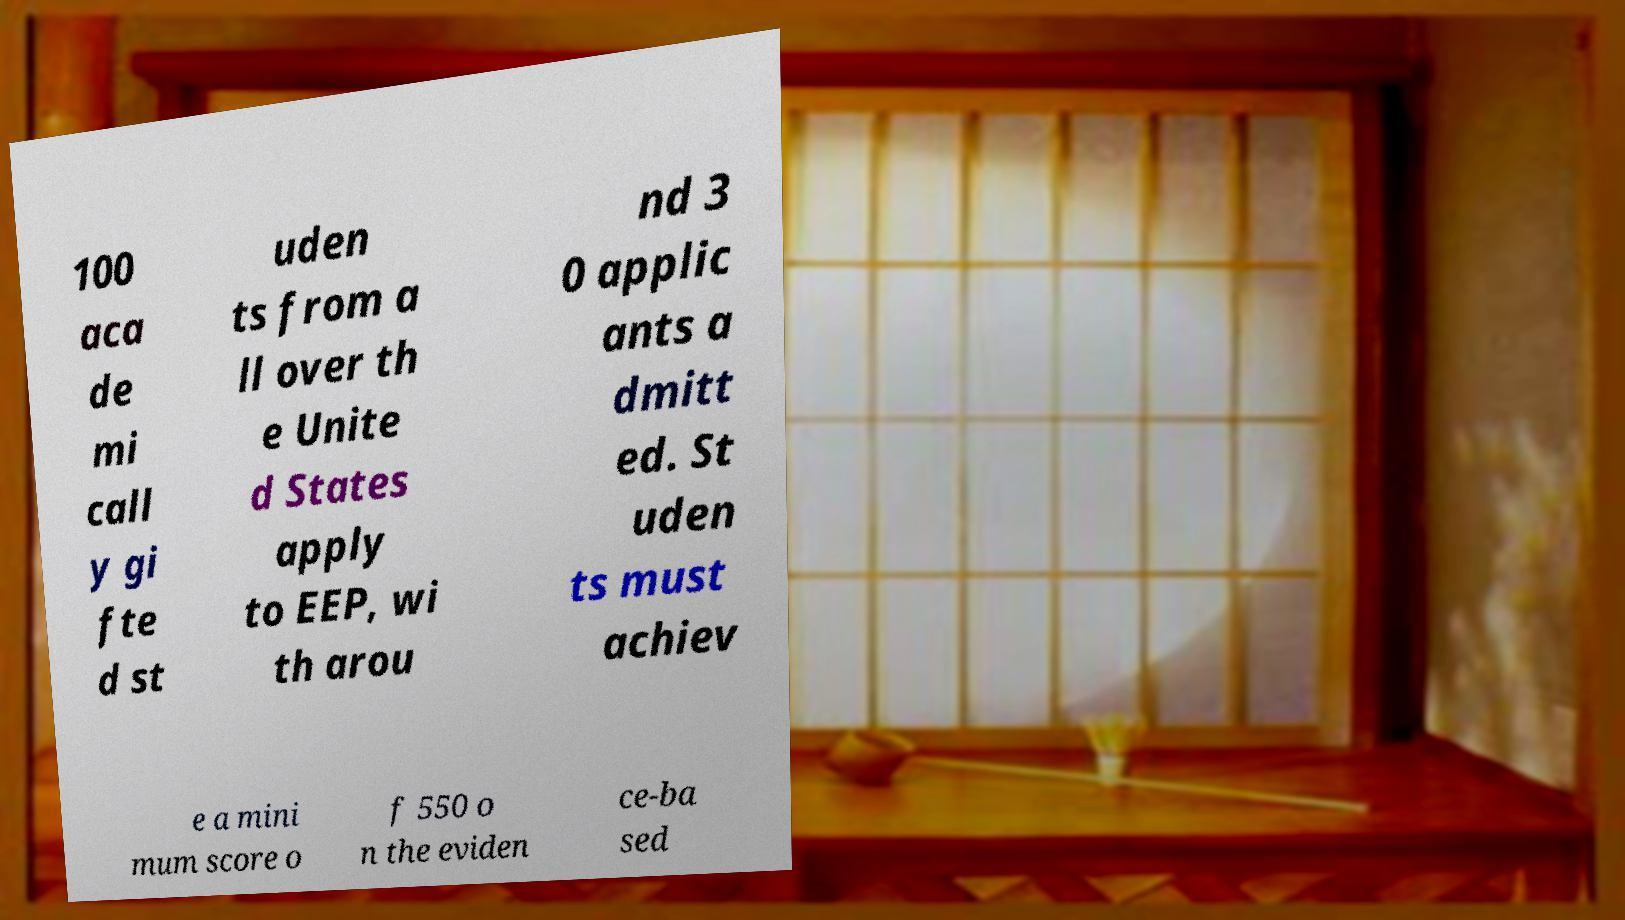Could you assist in decoding the text presented in this image and type it out clearly? 100 aca de mi call y gi fte d st uden ts from a ll over th e Unite d States apply to EEP, wi th arou nd 3 0 applic ants a dmitt ed. St uden ts must achiev e a mini mum score o f 550 o n the eviden ce-ba sed 